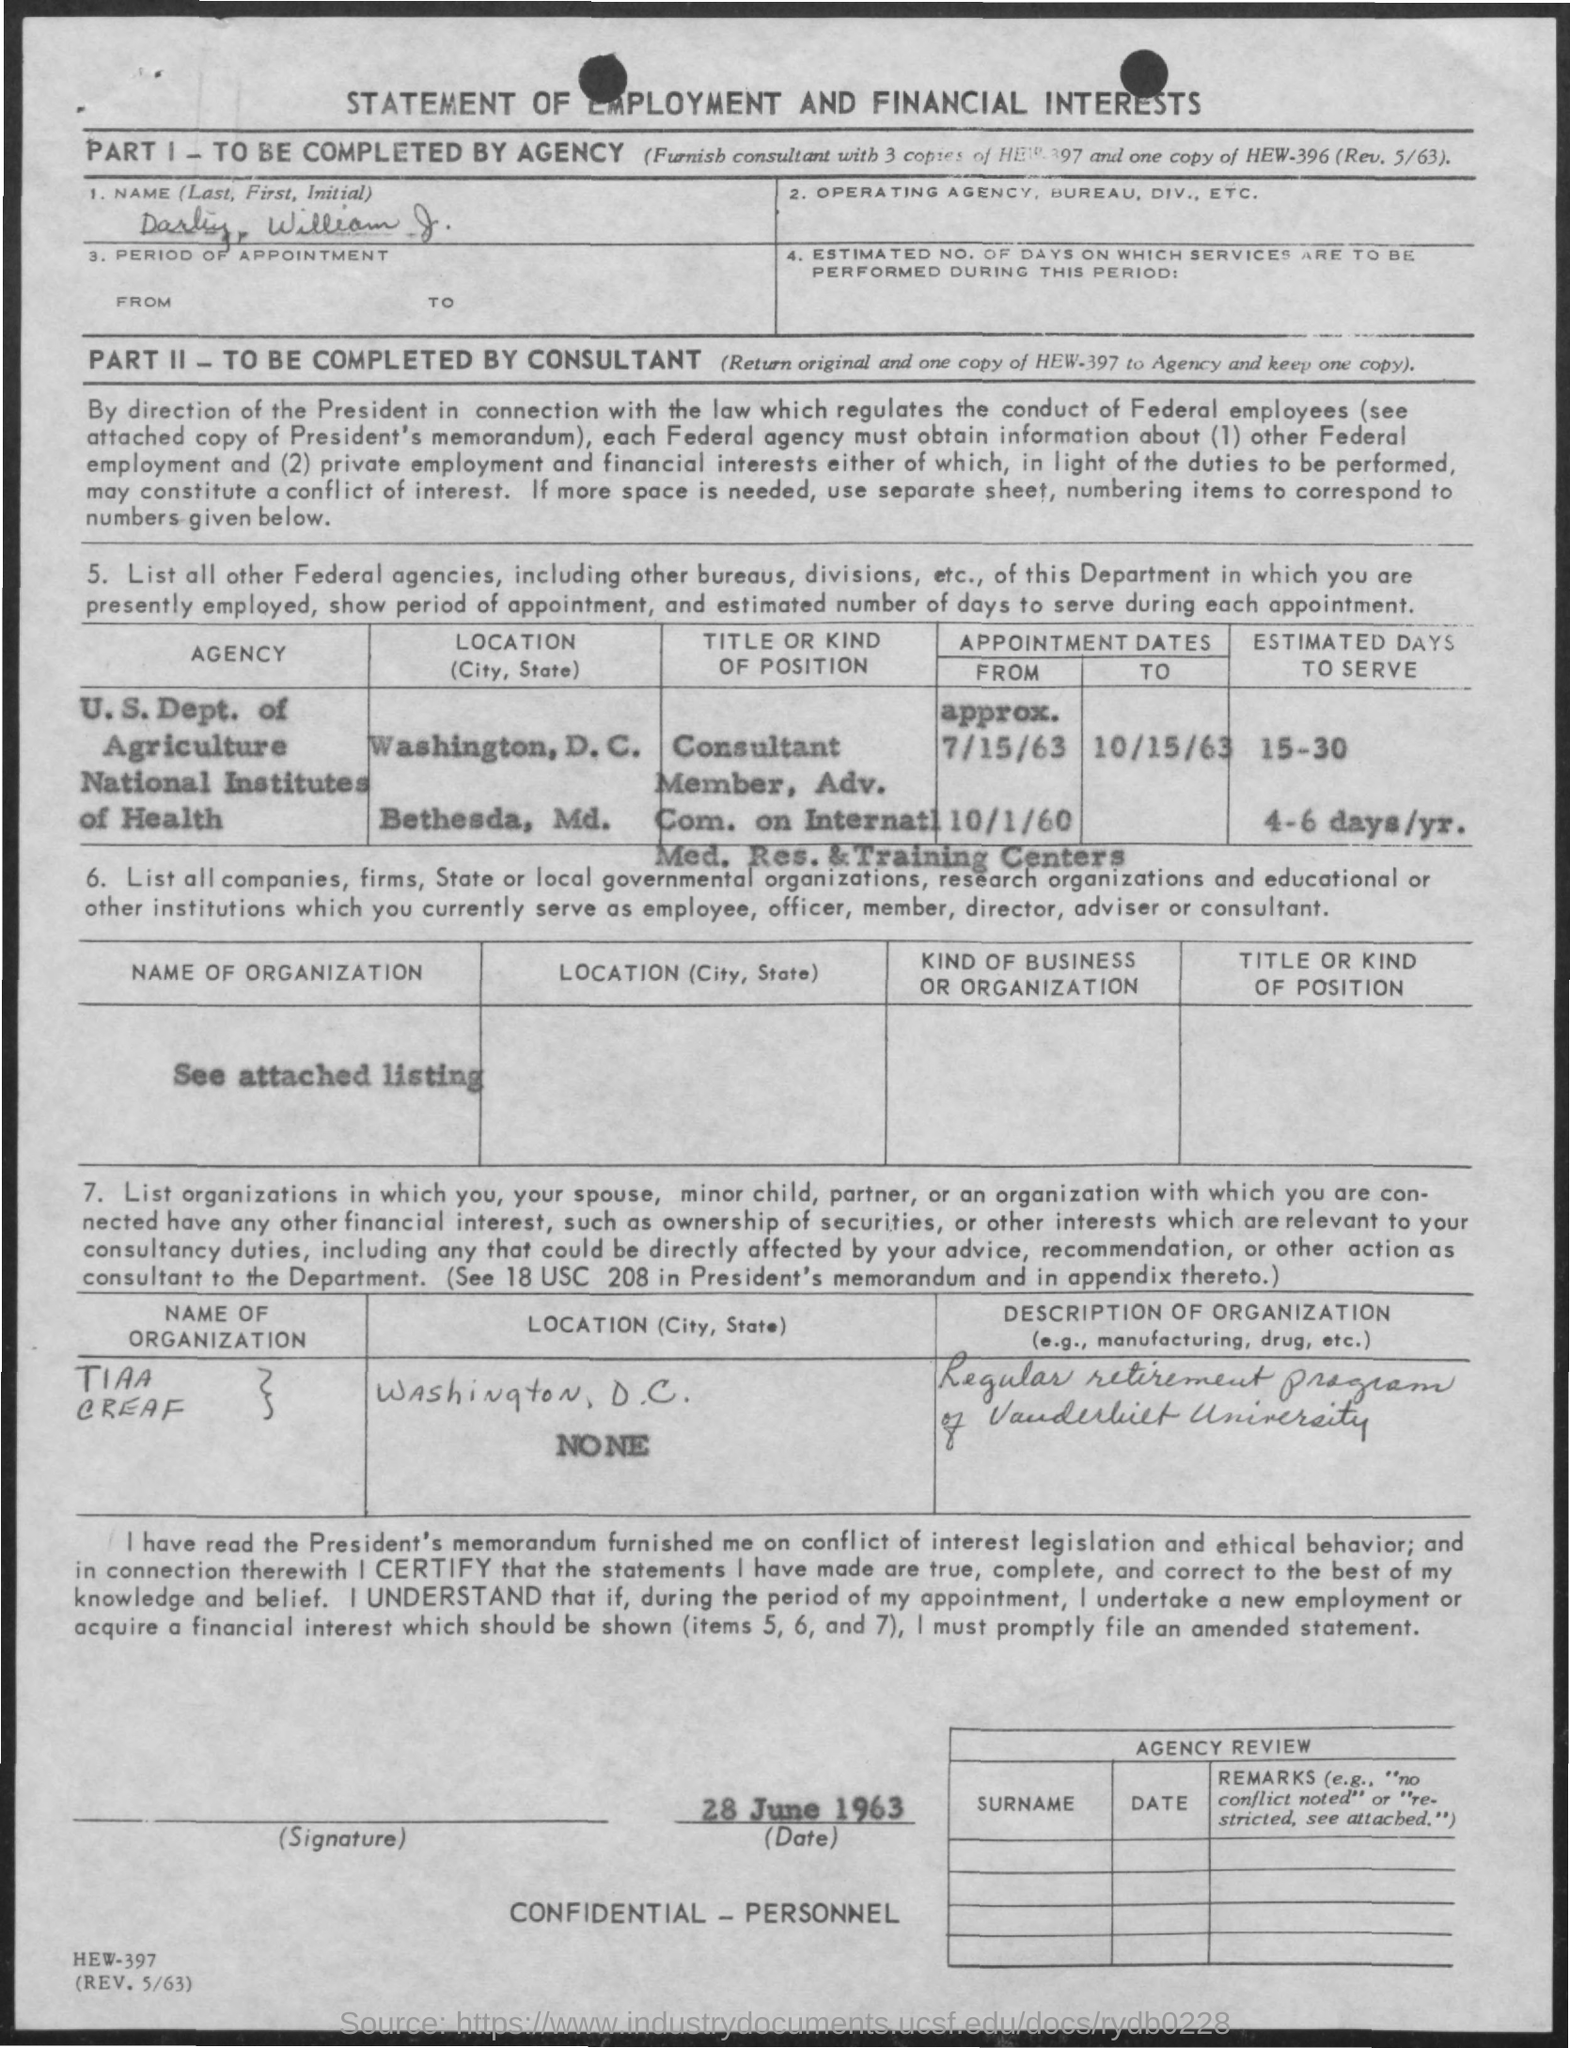What is the first name mentioned in the given application ?
Provide a succinct answer. William. What is the estimated days to serve in the u.s.dept. of agriculture ?
Provide a succinct answer. 15-30. Where is national institutes of health is located ?
Your response must be concise. Bethesda, md. What is the from appointment dates given for national institutes of health ?
Your response must be concise. 10/1/60. What is the estimated days to serve in national institutes of health ?
Give a very brief answer. 4-6 days/yr. What is the date mentioned in the given page ?
Make the answer very short. 28 JUNE 1963. What is the location of tiaa creaf organization ?
Your response must be concise. Washington. D.C. 